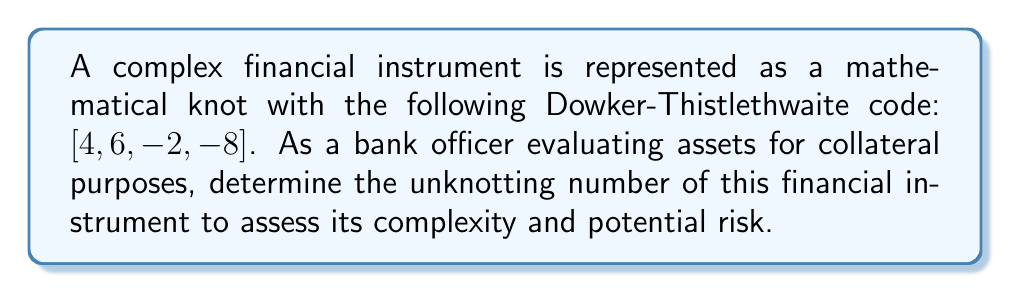Show me your answer to this math problem. To determine the unknotting number of the financial instrument represented by the knot, we'll follow these steps:

1. Interpret the Dowker-Thistlethwaite code:
   The code [4, 6, -2, -8] represents a knot with 4 crossings.

2. Identify the knot:
   This code corresponds to the figure-eight knot, also known as the 4₁ knot in the Alexander-Briggs notation.

3. Properties of the figure-eight knot:
   a) It is a prime knot
   b) It is amphichiral (equivalent to its mirror image)
   c) It has a crossing number of 4

4. Determine the unknotting number:
   For the figure-eight knot, the unknotting number is known to be 1. This means that a single crossing change is sufficient to transform the knot into the unknot (trivial knot).

5. Proof of unknotting number:
   a) Lower bound: The unknotting number must be at least 1 since the knot is non-trivial.
   b) Upper bound: We can demonstrate that one crossing change is sufficient:
      - Choose any crossing in the figure-eight knot diagram
      - Change this crossing (from over to under or vice versa)
      - The resulting diagram can be deformed into the unknot

6. Financial interpretation:
   The unknotting number of 1 suggests that this financial instrument has a moderate level of complexity. It can be simplified to a basic form (unknot) with a single fundamental change in its structure.
Answer: 1 